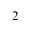<formula> <loc_0><loc_0><loc_500><loc_500>2</formula> 